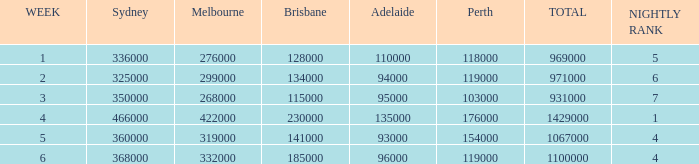What was the sum of ratings on the third week? 931000.0. Help me parse the entirety of this table. {'header': ['WEEK', 'Sydney', 'Melbourne', 'Brisbane', 'Adelaide', 'Perth', 'TOTAL', 'NIGHTLY RANK'], 'rows': [['1', '336000', '276000', '128000', '110000', '118000', '969000', '5'], ['2', '325000', '299000', '134000', '94000', '119000', '971000', '6'], ['3', '350000', '268000', '115000', '95000', '103000', '931000', '7'], ['4', '466000', '422000', '230000', '135000', '176000', '1429000', '1'], ['5', '360000', '319000', '141000', '93000', '154000', '1067000', '4'], ['6', '368000', '332000', '185000', '96000', '119000', '1100000', '4']]} 